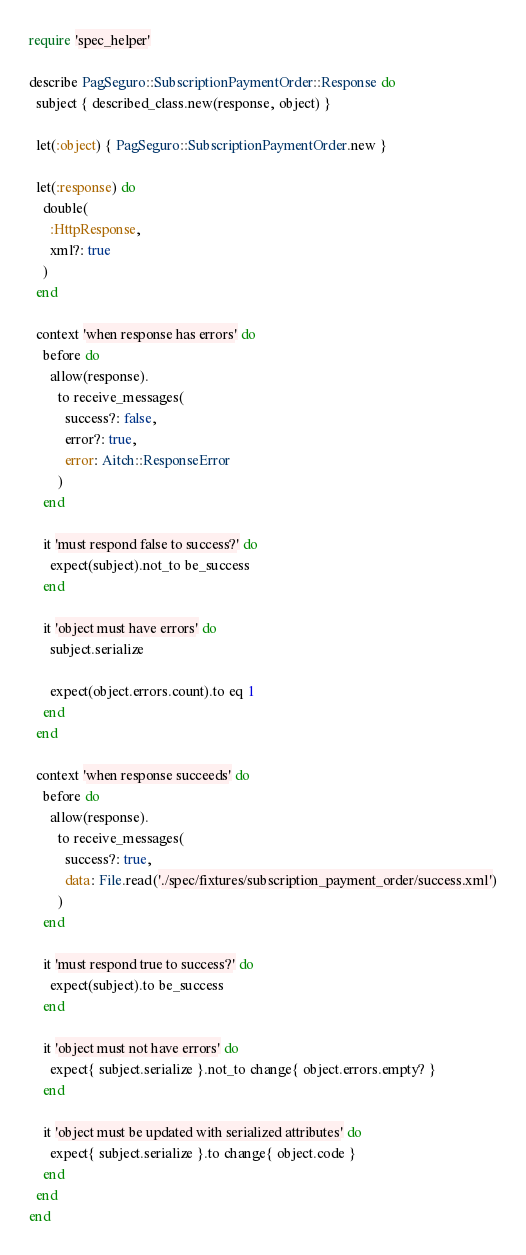Convert code to text. <code><loc_0><loc_0><loc_500><loc_500><_Ruby_>require 'spec_helper'

describe PagSeguro::SubscriptionPaymentOrder::Response do
  subject { described_class.new(response, object) }

  let(:object) { PagSeguro::SubscriptionPaymentOrder.new }

  let(:response) do
    double(
      :HttpResponse,
      xml?: true
    )
  end

  context 'when response has errors' do
    before do
      allow(response).
        to receive_messages(
          success?: false,
          error?: true,
          error: Aitch::ResponseError
        )
    end

    it 'must respond false to success?' do
      expect(subject).not_to be_success
    end

    it 'object must have errors' do
      subject.serialize
        
      expect(object.errors.count).to eq 1
    end
  end

  context 'when response succeeds' do
    before do
      allow(response).
        to receive_messages(
          success?: true,
          data: File.read('./spec/fixtures/subscription_payment_order/success.xml')
        )
    end

    it 'must respond true to success?' do
      expect(subject).to be_success
    end

    it 'object must not have errors' do
      expect{ subject.serialize }.not_to change{ object.errors.empty? }
    end

    it 'object must be updated with serialized attributes' do
      expect{ subject.serialize }.to change{ object.code }
    end
  end
end
</code> 